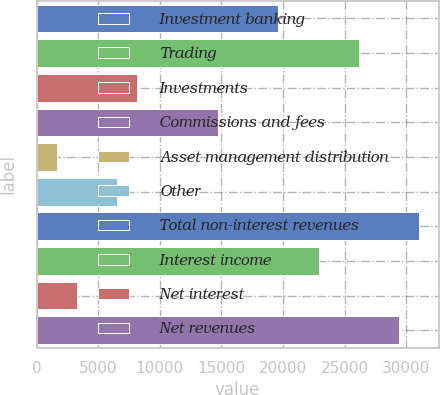Convert chart to OTSL. <chart><loc_0><loc_0><loc_500><loc_500><bar_chart><fcel>Investment banking<fcel>Trading<fcel>Investments<fcel>Commissions and fees<fcel>Asset management distribution<fcel>Other<fcel>Total non-interest revenues<fcel>Interest income<fcel>Net interest<fcel>Net revenues<nl><fcel>19623.4<fcel>26160.2<fcel>8184<fcel>14720.8<fcel>1647.2<fcel>6549.8<fcel>31062.8<fcel>22891.8<fcel>3281.4<fcel>29428.6<nl></chart> 